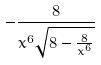<formula> <loc_0><loc_0><loc_500><loc_500>- \frac { 8 } { x ^ { 6 } \sqrt { 8 - \frac { 8 } { x ^ { 6 } } } }</formula> 